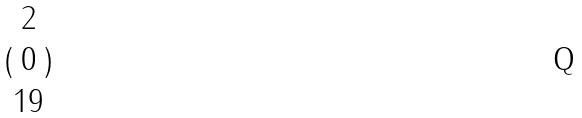<formula> <loc_0><loc_0><loc_500><loc_500>( \begin{matrix} 2 \\ 0 \\ 1 9 \end{matrix} )</formula> 